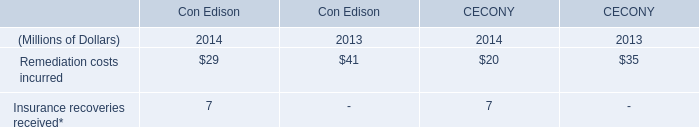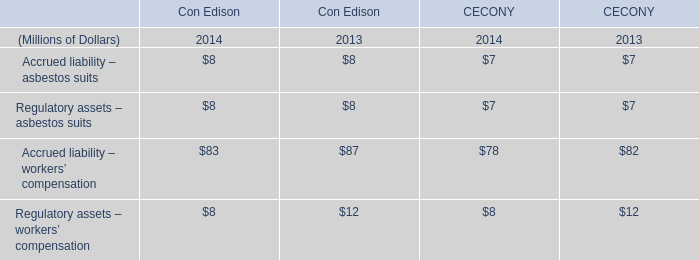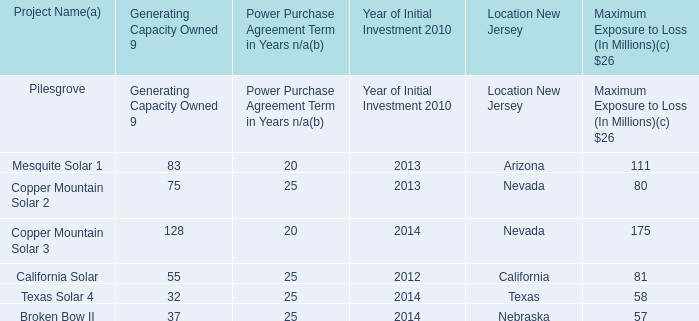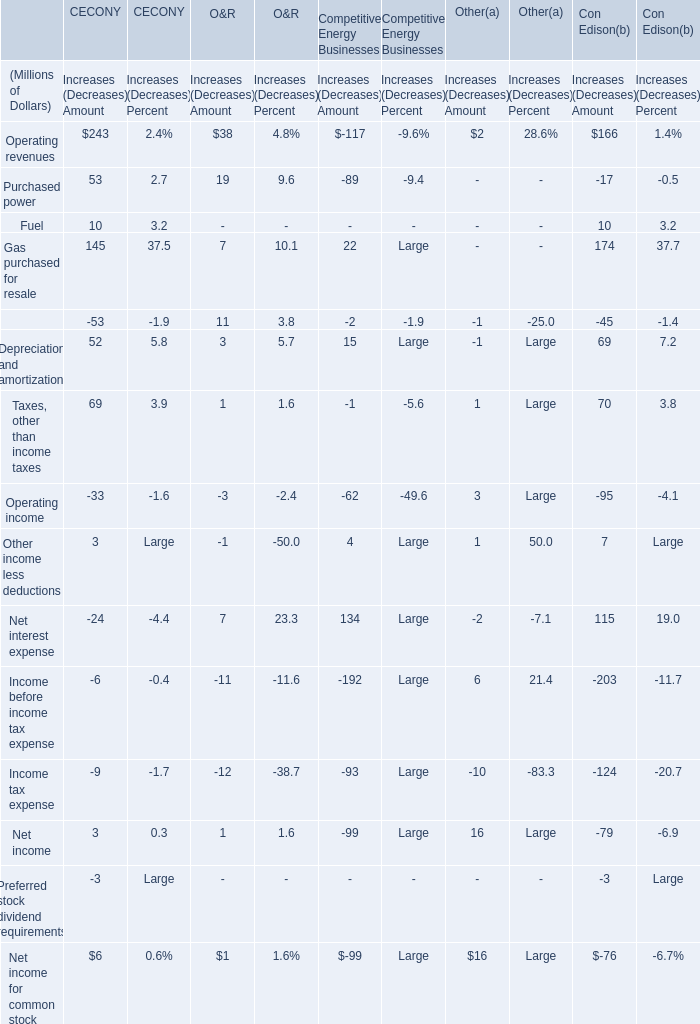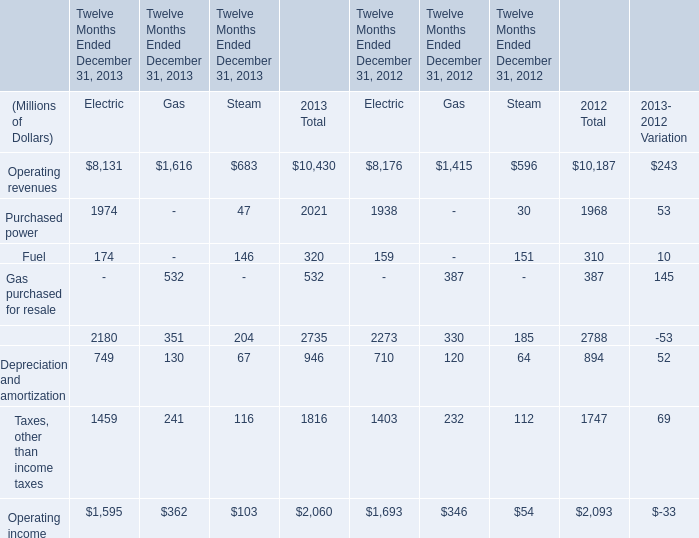What is the ratio of all Increases (Decreases) Amount that are smaller than 200 to the sum of Increases (Decreases) Amount, in Operating revenues? 
Computations: ((((38 - 117) + 2) + 166) / ((((38 - 117) + 2) + 166) + 243))
Answer: 0.26807. 